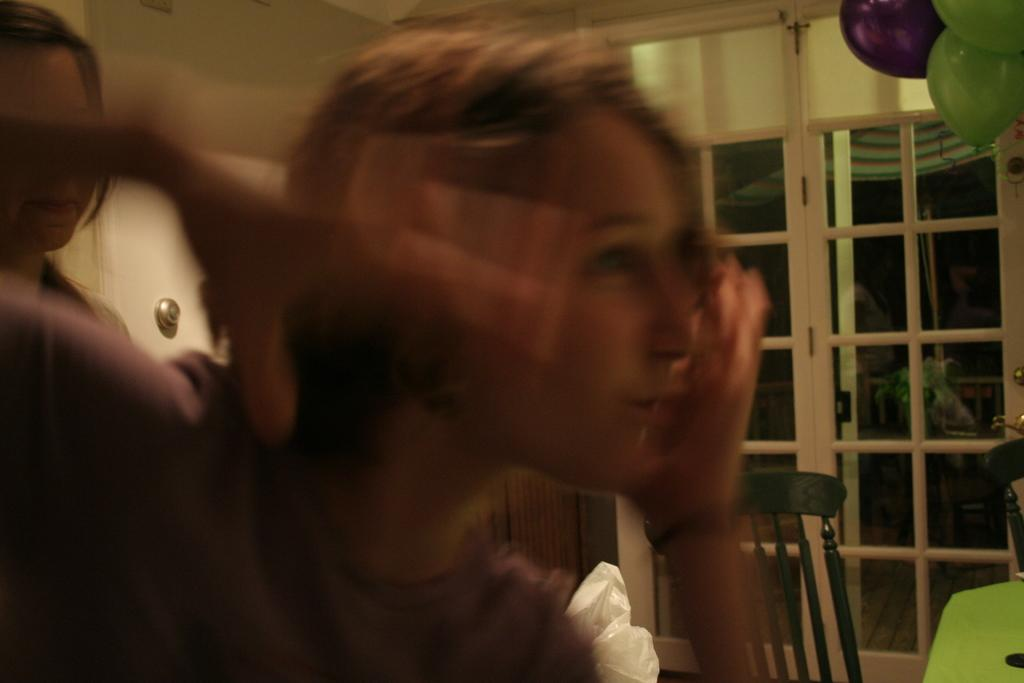Who is present in the image? There are women in the image. What can be seen in the background of the image? There is a door, a chair, and a wall in the background of the image. What type of fish can be seen attacking the women in the image? There is no fish present in the image, nor is there any indication of an attack. 